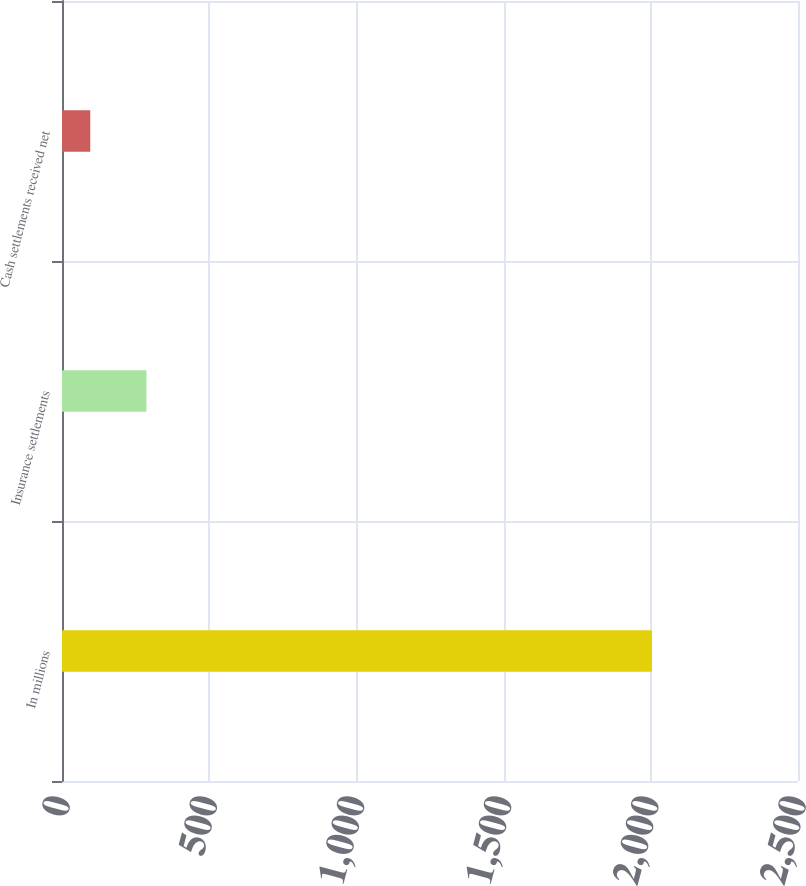Convert chart to OTSL. <chart><loc_0><loc_0><loc_500><loc_500><bar_chart><fcel>In millions<fcel>Insurance settlements<fcel>Cash settlements received net<nl><fcel>2004<fcel>286.8<fcel>96<nl></chart> 